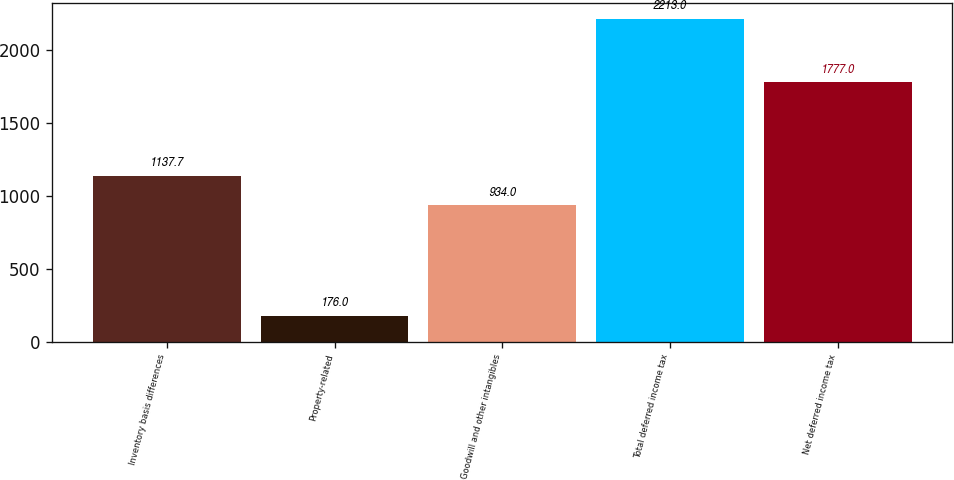<chart> <loc_0><loc_0><loc_500><loc_500><bar_chart><fcel>Inventory basis differences<fcel>Property-related<fcel>Goodwill and other intangibles<fcel>Total deferred income tax<fcel>Net deferred income tax<nl><fcel>1137.7<fcel>176<fcel>934<fcel>2213<fcel>1777<nl></chart> 